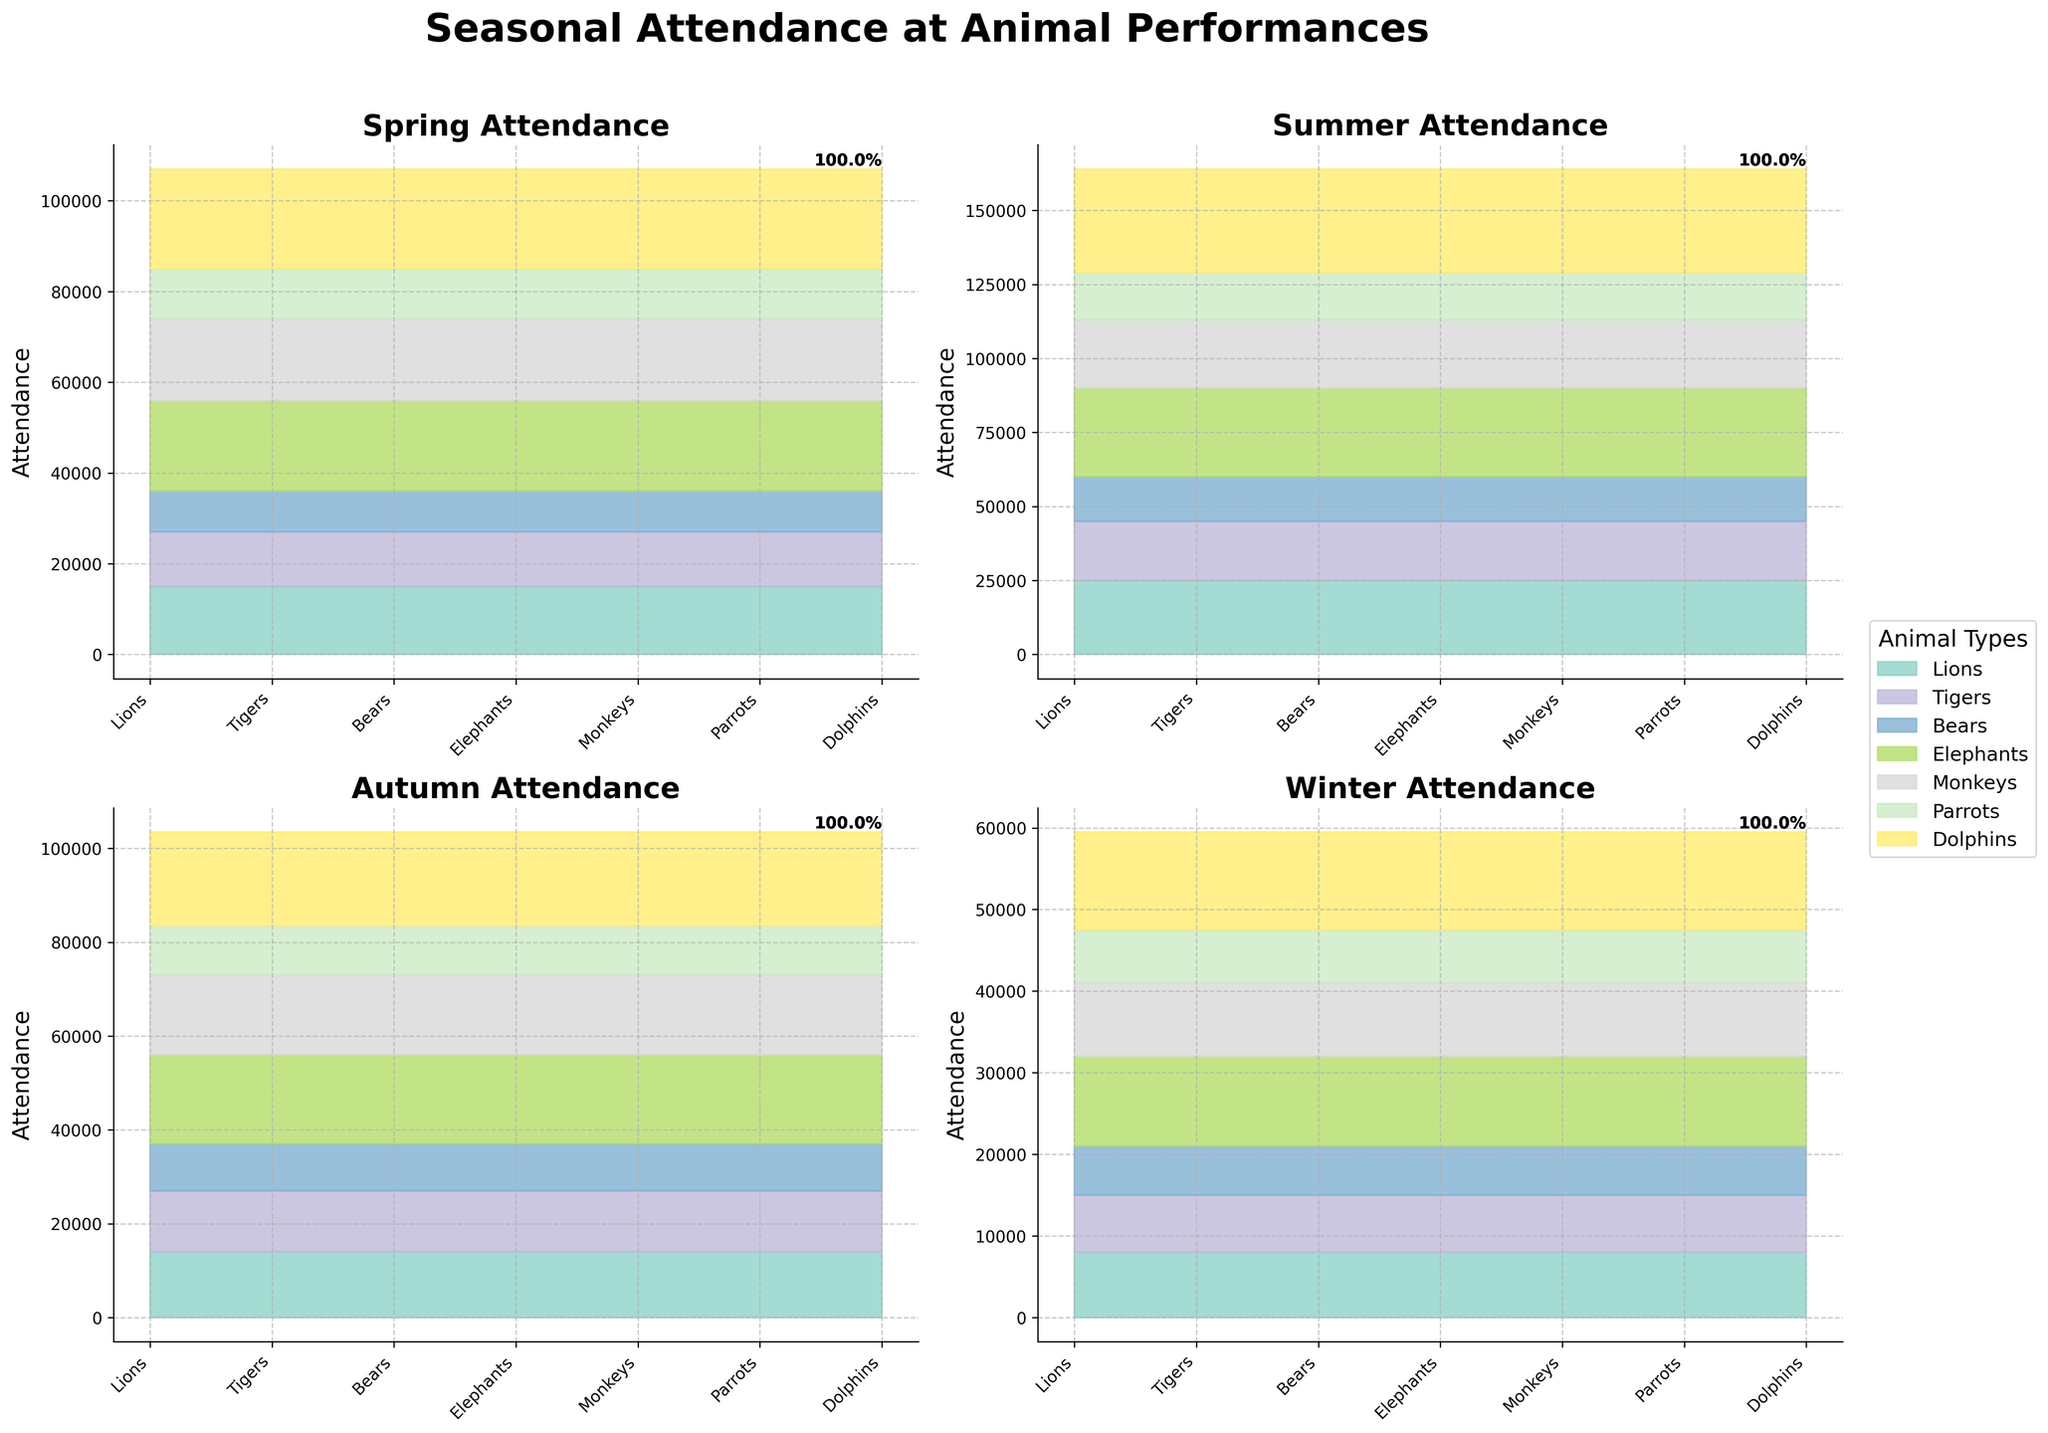What is the total attendance for Lions in summer? Look at the summer subplot within the multi-subplots. The attendance for Lions in summer is shown as 25000.
Answer: 25000 Which animal has the highest attendance in autumn? The subplot for autumn shows the attendance for various animals. Dolphins have the highest attendance in autumn with 20000.
Answer: Dolphins Compare the attendance of Elephants between spring and winter. Which season saw higher attendance? Elephants' attendance in spring is 20000, while in winter it is 11000. Comparing these two, spring has the higher attendance.
Answer: Spring What is the percentage contribution of Dolphins' attendance to the total attendance in spring? In the spring subplot, the total attendance is the sum of attendances which is 97000. Dolphins' attendance in spring is 22000. The percentage is (22000/97000)*100 = 22.7%.
Answer: 22.7% How much more attendance do Tigers get in summer compared to winter? Tigers' attendance in summer is 20000, and in winter it is 7000. The difference is 20000 - 7000 = 13000.
Answer: 13000 Which season has the least attendance for Monkeys? Compare the Monkeys' attendance across all subplots (seasons). The attendance for Monkeys in winter is 9000, which is the least.
Answer: Winter If you sum the attendance for Parrots across all seasons, what is the total? Add Parrots' attendance for each season: 11000 (spring) + 16000 (summer) + 10500 (autumn) + 6500 (winter) = 44000.
Answer: 44000 Do Elephants have higher attendance in autumn than Lions in summer? The attendance for Elephants in autumn is 19000, while the attendance for Lions in summer is 25000. Therefore, Lions in summer have higher attendance.
Answer: No Rank the seasons based on Bears' attendance from highest to lowest. Bears' attendance by season is:
- Summer: 15000
- Autumn: 10000
- Spring: 9000
- Winter: 6000
Ranking them from highest to lowest gives: Summer, Autumn, Spring, Winter.
Answer: Summer, Autumn, Spring, Winter What's the combined attendance for Dolphins and Monkeys in summer? Dolphins' attendance in summer is 35000, and Monkeys' attendance is 23000. The combined attendance is 35000 + 23000 = 58000.
Answer: 58000 